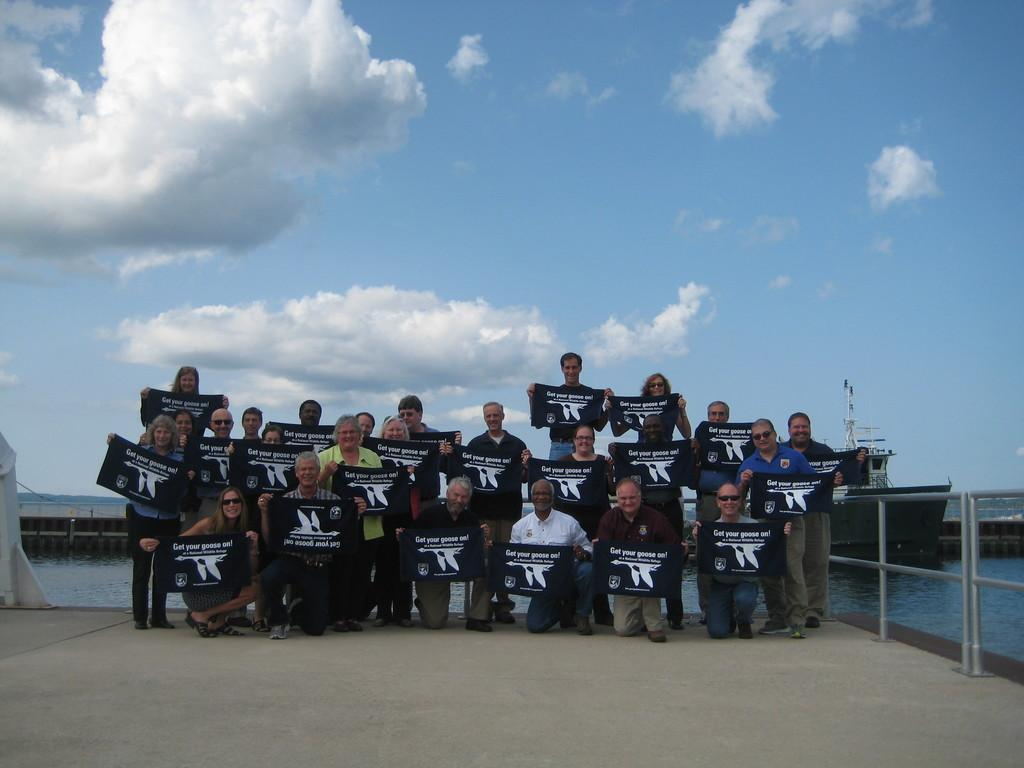What are the people in the image holding? The people in the image are holding banners. What is located beside the people? There is a railing beside the people. What can be seen on the water in the image? There is a ship on the water in the image. What type of structure is present in the image? There is a bridge in the image. What is visible in the background of the image? The sky is visible in the background of the image. What can be observed in the sky? Clouds are present in the sky. How many grapes are being held by the men in the image? There are no men or grapes present in the image. What type of ticket is required to board the ship in the image? There is no mention of a ticket or boarding the ship in the image. 